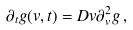<formula> <loc_0><loc_0><loc_500><loc_500>\partial _ { t } g ( v , t ) = D v \partial ^ { 2 } _ { v } g \, ,</formula> 